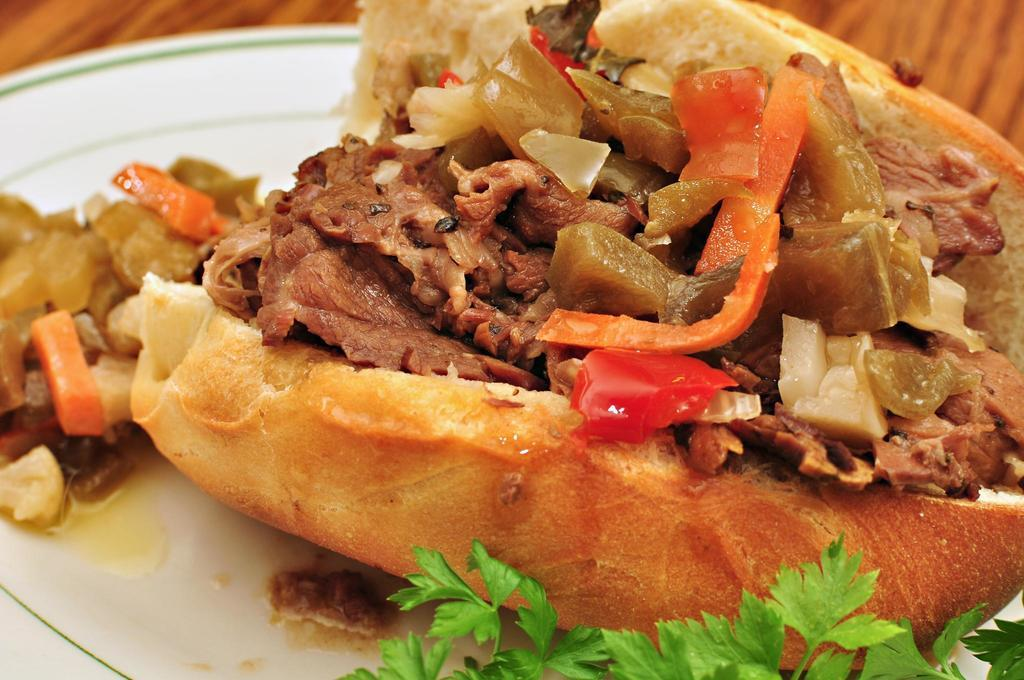What is located in the center of the image? There is a table in the center of the image. What is on top of the table? There is a plate on the table. What can be found on the plate? The plate contains a food item. What type of gold jewelry is the person wearing in the image? There is no person or gold jewelry present in the image; it only features a table, a plate, and a food item. 